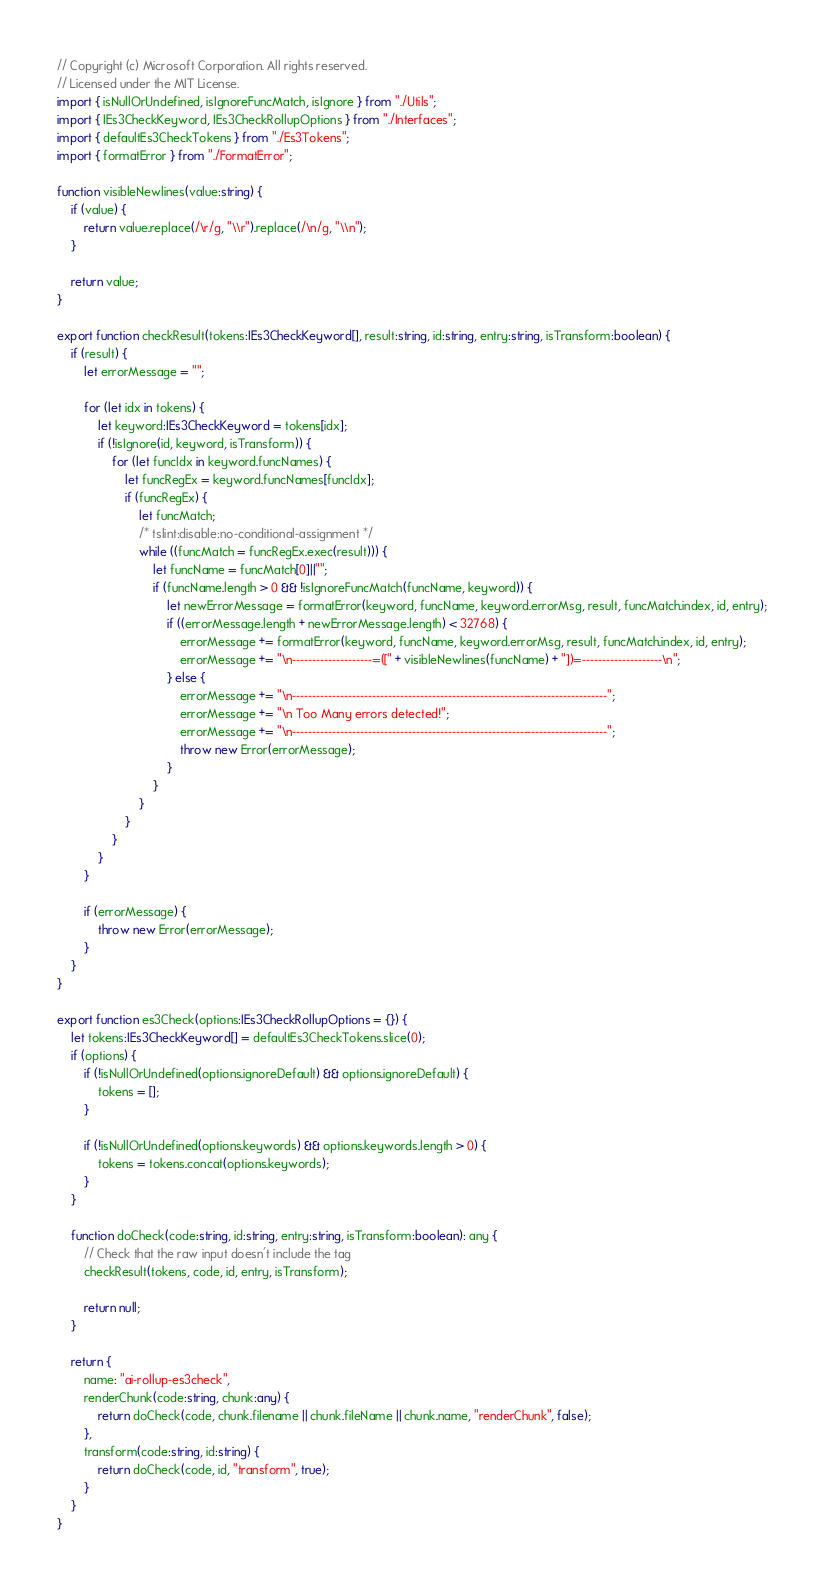<code> <loc_0><loc_0><loc_500><loc_500><_TypeScript_>// Copyright (c) Microsoft Corporation. All rights reserved.
// Licensed under the MIT License.
import { isNullOrUndefined, isIgnoreFuncMatch, isIgnore } from "./Utils";
import { IEs3CheckKeyword, IEs3CheckRollupOptions } from "./Interfaces";
import { defaultEs3CheckTokens } from "./Es3Tokens";
import { formatError } from "./FormatError";

function visibleNewlines(value:string) {
    if (value) {
        return value.replace(/\r/g, "\\r").replace(/\n/g, "\\n");
    }

    return value;
}

export function checkResult(tokens:IEs3CheckKeyword[], result:string, id:string, entry:string, isTransform:boolean) {
    if (result) {
        let errorMessage = "";

        for (let idx in tokens) {
            let keyword:IEs3CheckKeyword = tokens[idx];
            if (!isIgnore(id, keyword, isTransform)) {
                for (let funcIdx in keyword.funcNames) {
                    let funcRegEx = keyword.funcNames[funcIdx];
                    if (funcRegEx) {
                        let funcMatch;
                        /* tslint:disable:no-conditional-assignment */
                        while ((funcMatch = funcRegEx.exec(result))) {
                            let funcName = funcMatch[0]||"";
                            if (funcName.length > 0 && !isIgnoreFuncMatch(funcName, keyword)) {
                                let newErrorMessage = formatError(keyword, funcName, keyword.errorMsg, result, funcMatch.index, id, entry);
                                if ((errorMessage.length + newErrorMessage.length) < 32768) {
                                    errorMessage += formatError(keyword, funcName, keyword.errorMsg, result, funcMatch.index, id, entry);
                                    errorMessage += "\n--------------------=([" + visibleNewlines(funcName) + "])=--------------------\n";
                                } else {
                                    errorMessage += "\n-------------------------------------------------------------------------------";
                                    errorMessage += "\n Too Many errors detected!";
                                    errorMessage += "\n-------------------------------------------------------------------------------";
                                    throw new Error(errorMessage);
                                }
                            }
                        }
                    }
                }
            }
        }

        if (errorMessage) {
            throw new Error(errorMessage);
        }
    }
}

export function es3Check(options:IEs3CheckRollupOptions = {}) {
    let tokens:IEs3CheckKeyword[] = defaultEs3CheckTokens.slice(0);
    if (options) {
        if (!isNullOrUndefined(options.ignoreDefault) && options.ignoreDefault) {
            tokens = [];
        }

        if (!isNullOrUndefined(options.keywords) && options.keywords.length > 0) {
            tokens = tokens.concat(options.keywords);
        }
    }

    function doCheck(code:string, id:string, entry:string, isTransform:boolean): any {
        // Check that the raw input doesn't include the tag
        checkResult(tokens, code, id, entry, isTransform);

        return null;
    }

    return {
        name: "ai-rollup-es3check",
        renderChunk(code:string, chunk:any) {
            return doCheck(code, chunk.filename || chunk.fileName || chunk.name, "renderChunk", false);
        },
        transform(code:string, id:string) {
            return doCheck(code, id, "transform", true);
        }
    }
}</code> 